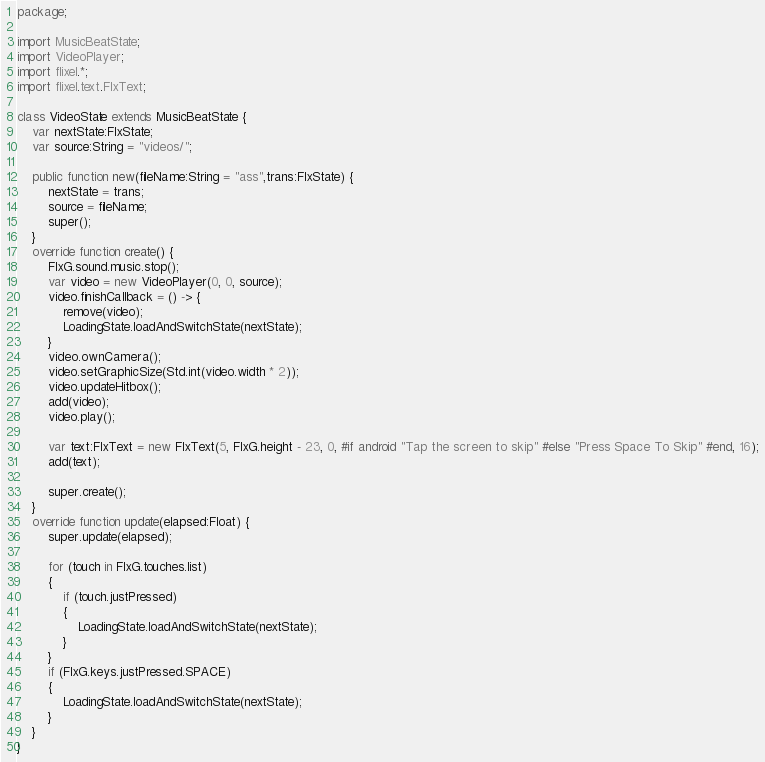<code> <loc_0><loc_0><loc_500><loc_500><_Haxe_>package;

import MusicBeatState;
import VideoPlayer;
import flixel.*;
import flixel.text.FlxText;

class VideoState extends MusicBeatState {
    var nextState:FlxState;
    var source:String = "videos/";

    public function new(fileName:String = "ass",trans:FlxState) {
        nextState = trans;
        source = fileName;
        super();
    }
    override function create() {
        FlxG.sound.music.stop();
        var video = new VideoPlayer(0, 0, source);
		video.finishCallback = () -> {
			remove(video);
            LoadingState.loadAndSwitchState(nextState);
		}
		video.ownCamera();
        video.setGraphicSize(Std.int(video.width * 2));
		video.updateHitbox();
		add(video);
		video.play();

        var text:FlxText = new FlxText(5, FlxG.height - 23, 0, #if android "Tap the screen to skip" #else "Press Space To Skip" #end, 16);
        add(text);

        super.create();
    }
    override function update(elapsed:Float) {
        super.update(elapsed);

        for (touch in FlxG.touches.list)
        {
            if (touch.justPressed)
            {
                LoadingState.loadAndSwitchState(nextState);
            }
        }
        if (FlxG.keys.justPressed.SPACE)
        {
            LoadingState.loadAndSwitchState(nextState);
        }
    }
}</code> 